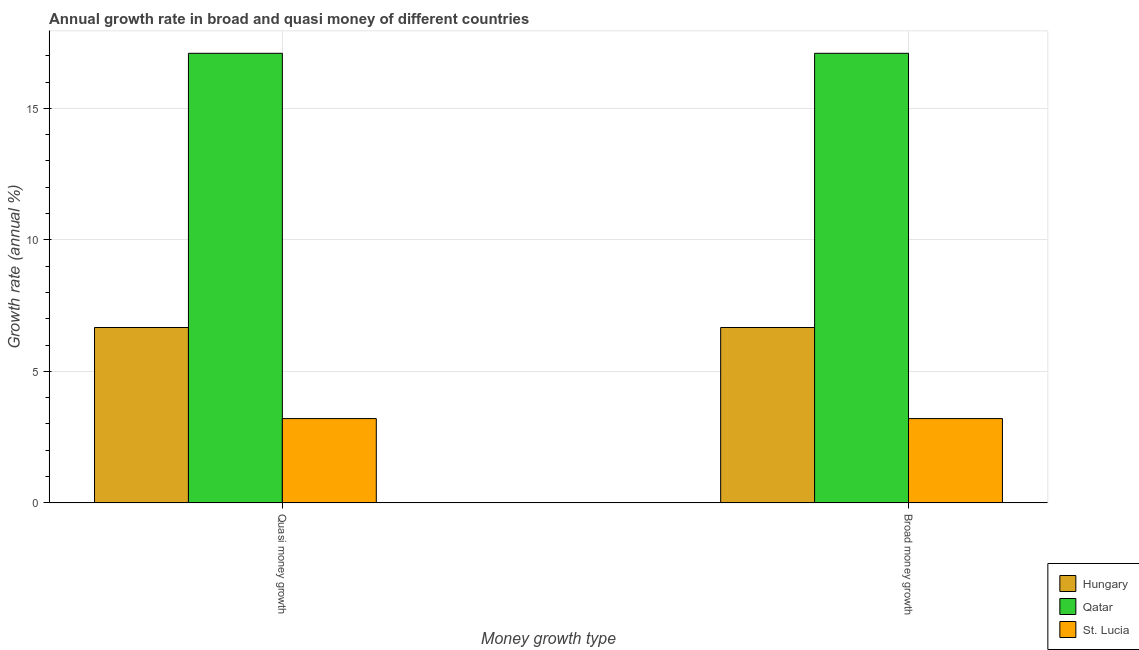How many different coloured bars are there?
Offer a terse response. 3. Are the number of bars per tick equal to the number of legend labels?
Make the answer very short. Yes. Are the number of bars on each tick of the X-axis equal?
Provide a succinct answer. Yes. How many bars are there on the 2nd tick from the left?
Offer a very short reply. 3. How many bars are there on the 2nd tick from the right?
Your answer should be very brief. 3. What is the label of the 1st group of bars from the left?
Give a very brief answer. Quasi money growth. What is the annual growth rate in quasi money in Qatar?
Keep it short and to the point. 17.09. Across all countries, what is the maximum annual growth rate in quasi money?
Your answer should be compact. 17.09. Across all countries, what is the minimum annual growth rate in broad money?
Your response must be concise. 3.2. In which country was the annual growth rate in broad money maximum?
Provide a succinct answer. Qatar. In which country was the annual growth rate in quasi money minimum?
Ensure brevity in your answer.  St. Lucia. What is the total annual growth rate in broad money in the graph?
Your response must be concise. 26.96. What is the difference between the annual growth rate in quasi money in St. Lucia and that in Hungary?
Your answer should be very brief. -3.46. What is the difference between the annual growth rate in quasi money in Hungary and the annual growth rate in broad money in St. Lucia?
Your response must be concise. 3.46. What is the average annual growth rate in broad money per country?
Your answer should be compact. 8.99. What is the difference between the annual growth rate in broad money and annual growth rate in quasi money in Hungary?
Ensure brevity in your answer.  0. What is the ratio of the annual growth rate in broad money in Qatar to that in Hungary?
Your response must be concise. 2.56. In how many countries, is the annual growth rate in quasi money greater than the average annual growth rate in quasi money taken over all countries?
Your answer should be compact. 1. What does the 1st bar from the left in Quasi money growth represents?
Your response must be concise. Hungary. What does the 2nd bar from the right in Quasi money growth represents?
Give a very brief answer. Qatar. How many countries are there in the graph?
Provide a short and direct response. 3. What is the difference between two consecutive major ticks on the Y-axis?
Offer a very short reply. 5. Where does the legend appear in the graph?
Ensure brevity in your answer.  Bottom right. How many legend labels are there?
Ensure brevity in your answer.  3. How are the legend labels stacked?
Offer a very short reply. Vertical. What is the title of the graph?
Offer a terse response. Annual growth rate in broad and quasi money of different countries. What is the label or title of the X-axis?
Your answer should be very brief. Money growth type. What is the label or title of the Y-axis?
Provide a short and direct response. Growth rate (annual %). What is the Growth rate (annual %) in Hungary in Quasi money growth?
Offer a very short reply. 6.67. What is the Growth rate (annual %) of Qatar in Quasi money growth?
Your response must be concise. 17.09. What is the Growth rate (annual %) in St. Lucia in Quasi money growth?
Provide a short and direct response. 3.2. What is the Growth rate (annual %) of Hungary in Broad money growth?
Make the answer very short. 6.67. What is the Growth rate (annual %) in Qatar in Broad money growth?
Keep it short and to the point. 17.09. What is the Growth rate (annual %) in St. Lucia in Broad money growth?
Your answer should be compact. 3.2. Across all Money growth type, what is the maximum Growth rate (annual %) in Hungary?
Offer a very short reply. 6.67. Across all Money growth type, what is the maximum Growth rate (annual %) of Qatar?
Your response must be concise. 17.09. Across all Money growth type, what is the maximum Growth rate (annual %) of St. Lucia?
Offer a terse response. 3.2. Across all Money growth type, what is the minimum Growth rate (annual %) in Hungary?
Offer a terse response. 6.67. Across all Money growth type, what is the minimum Growth rate (annual %) in Qatar?
Provide a short and direct response. 17.09. Across all Money growth type, what is the minimum Growth rate (annual %) of St. Lucia?
Offer a terse response. 3.2. What is the total Growth rate (annual %) of Hungary in the graph?
Keep it short and to the point. 13.33. What is the total Growth rate (annual %) of Qatar in the graph?
Offer a terse response. 34.19. What is the total Growth rate (annual %) in St. Lucia in the graph?
Offer a terse response. 6.41. What is the difference between the Growth rate (annual %) in Hungary in Quasi money growth and that in Broad money growth?
Provide a succinct answer. 0. What is the difference between the Growth rate (annual %) of Qatar in Quasi money growth and that in Broad money growth?
Offer a very short reply. 0. What is the difference between the Growth rate (annual %) of Hungary in Quasi money growth and the Growth rate (annual %) of Qatar in Broad money growth?
Your answer should be compact. -10.43. What is the difference between the Growth rate (annual %) of Hungary in Quasi money growth and the Growth rate (annual %) of St. Lucia in Broad money growth?
Offer a terse response. 3.46. What is the difference between the Growth rate (annual %) in Qatar in Quasi money growth and the Growth rate (annual %) in St. Lucia in Broad money growth?
Provide a short and direct response. 13.89. What is the average Growth rate (annual %) in Hungary per Money growth type?
Give a very brief answer. 6.67. What is the average Growth rate (annual %) of Qatar per Money growth type?
Make the answer very short. 17.09. What is the average Growth rate (annual %) of St. Lucia per Money growth type?
Your response must be concise. 3.2. What is the difference between the Growth rate (annual %) in Hungary and Growth rate (annual %) in Qatar in Quasi money growth?
Keep it short and to the point. -10.43. What is the difference between the Growth rate (annual %) of Hungary and Growth rate (annual %) of St. Lucia in Quasi money growth?
Your answer should be compact. 3.46. What is the difference between the Growth rate (annual %) in Qatar and Growth rate (annual %) in St. Lucia in Quasi money growth?
Provide a succinct answer. 13.89. What is the difference between the Growth rate (annual %) in Hungary and Growth rate (annual %) in Qatar in Broad money growth?
Provide a short and direct response. -10.43. What is the difference between the Growth rate (annual %) in Hungary and Growth rate (annual %) in St. Lucia in Broad money growth?
Make the answer very short. 3.46. What is the difference between the Growth rate (annual %) in Qatar and Growth rate (annual %) in St. Lucia in Broad money growth?
Provide a succinct answer. 13.89. What is the ratio of the Growth rate (annual %) in Hungary in Quasi money growth to that in Broad money growth?
Ensure brevity in your answer.  1. What is the ratio of the Growth rate (annual %) of Qatar in Quasi money growth to that in Broad money growth?
Provide a succinct answer. 1. What is the ratio of the Growth rate (annual %) in St. Lucia in Quasi money growth to that in Broad money growth?
Your response must be concise. 1. What is the difference between the highest and the second highest Growth rate (annual %) in Hungary?
Your answer should be compact. 0. What is the difference between the highest and the second highest Growth rate (annual %) in Qatar?
Make the answer very short. 0. What is the difference between the highest and the second highest Growth rate (annual %) of St. Lucia?
Your answer should be very brief. 0. What is the difference between the highest and the lowest Growth rate (annual %) of Qatar?
Provide a succinct answer. 0. What is the difference between the highest and the lowest Growth rate (annual %) in St. Lucia?
Offer a very short reply. 0. 